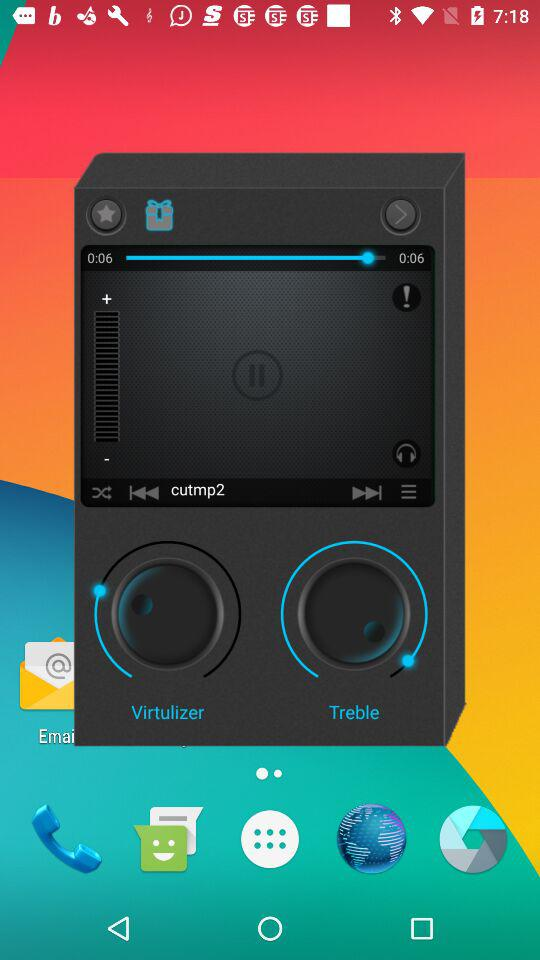What is the total duration? The total duration is 0:06. 